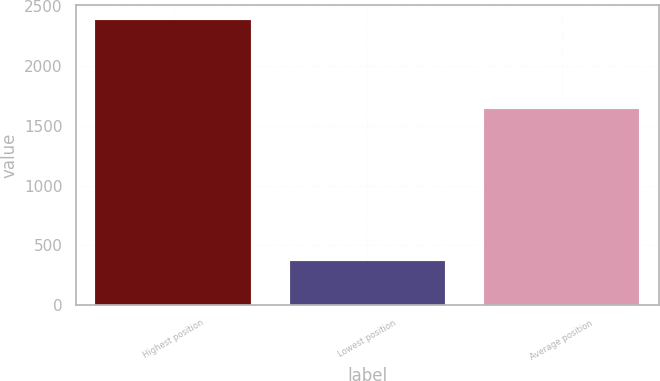<chart> <loc_0><loc_0><loc_500><loc_500><bar_chart><fcel>Highest position<fcel>Lowest position<fcel>Average position<nl><fcel>2388<fcel>368<fcel>1644<nl></chart> 